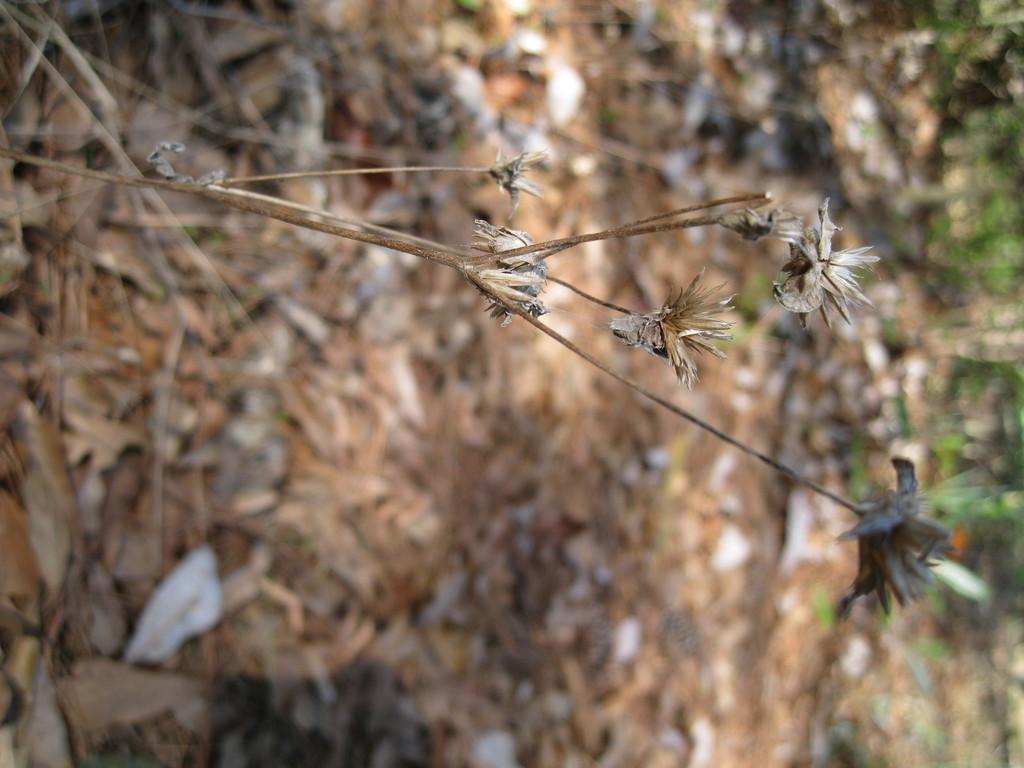Could you give a brief overview of what you see in this image? There is a dried plant with dried flowers. In the background it is blurred. 